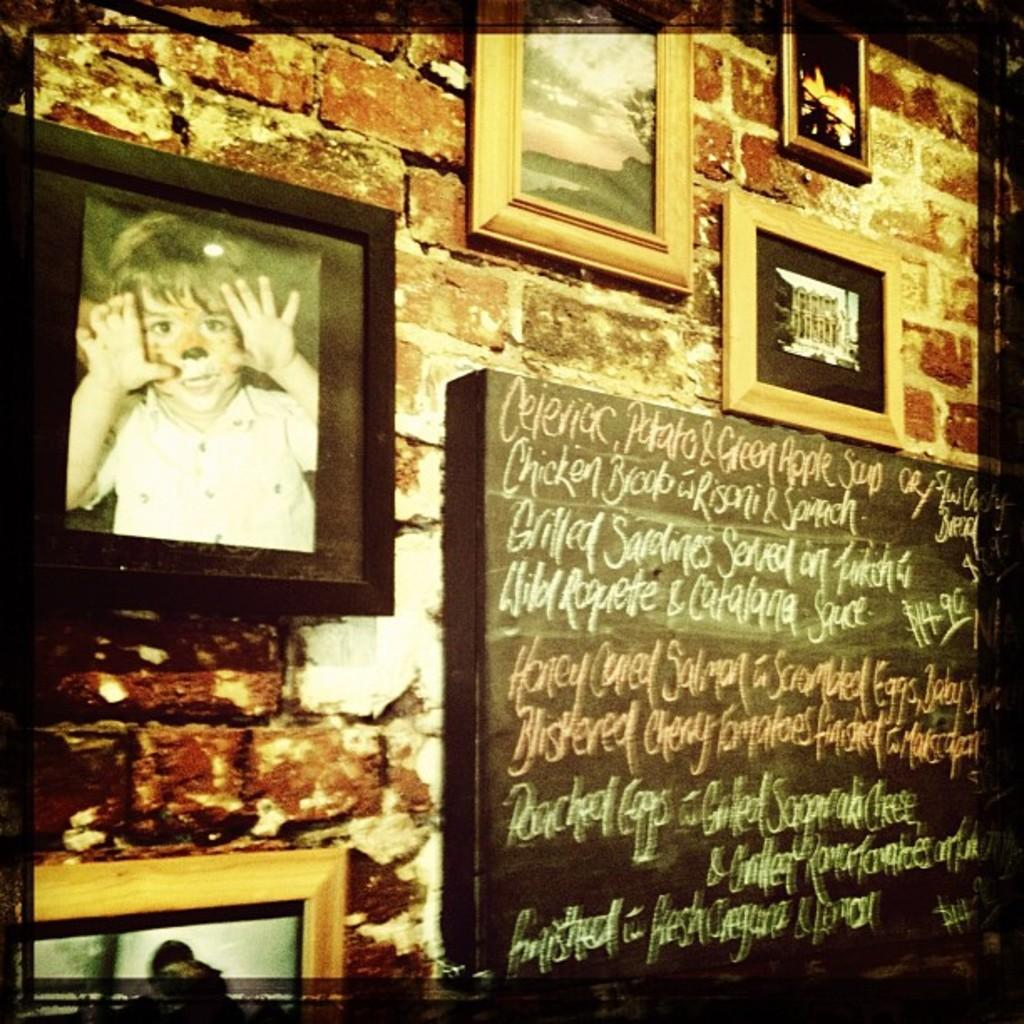What is present on the wall in the image? The wall has many wall hangings in the image. What else can be seen on the wall besides the wall hangings? There is a board with text in the image. How many people are jumping on the wall in the image? There are no people jumping on the wall in the image. What type of health information is displayed on the board in the image? There is no health information displayed on the board in the image; it only contains text. 